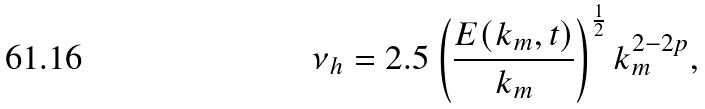Convert formula to latex. <formula><loc_0><loc_0><loc_500><loc_500>\nu _ { h } = 2 . 5 \left ( \frac { E ( k _ { m } , t ) } { k _ { m } } \right ) ^ { \frac { 1 } { 2 } } k _ { m } ^ { 2 - 2 p } ,</formula> 